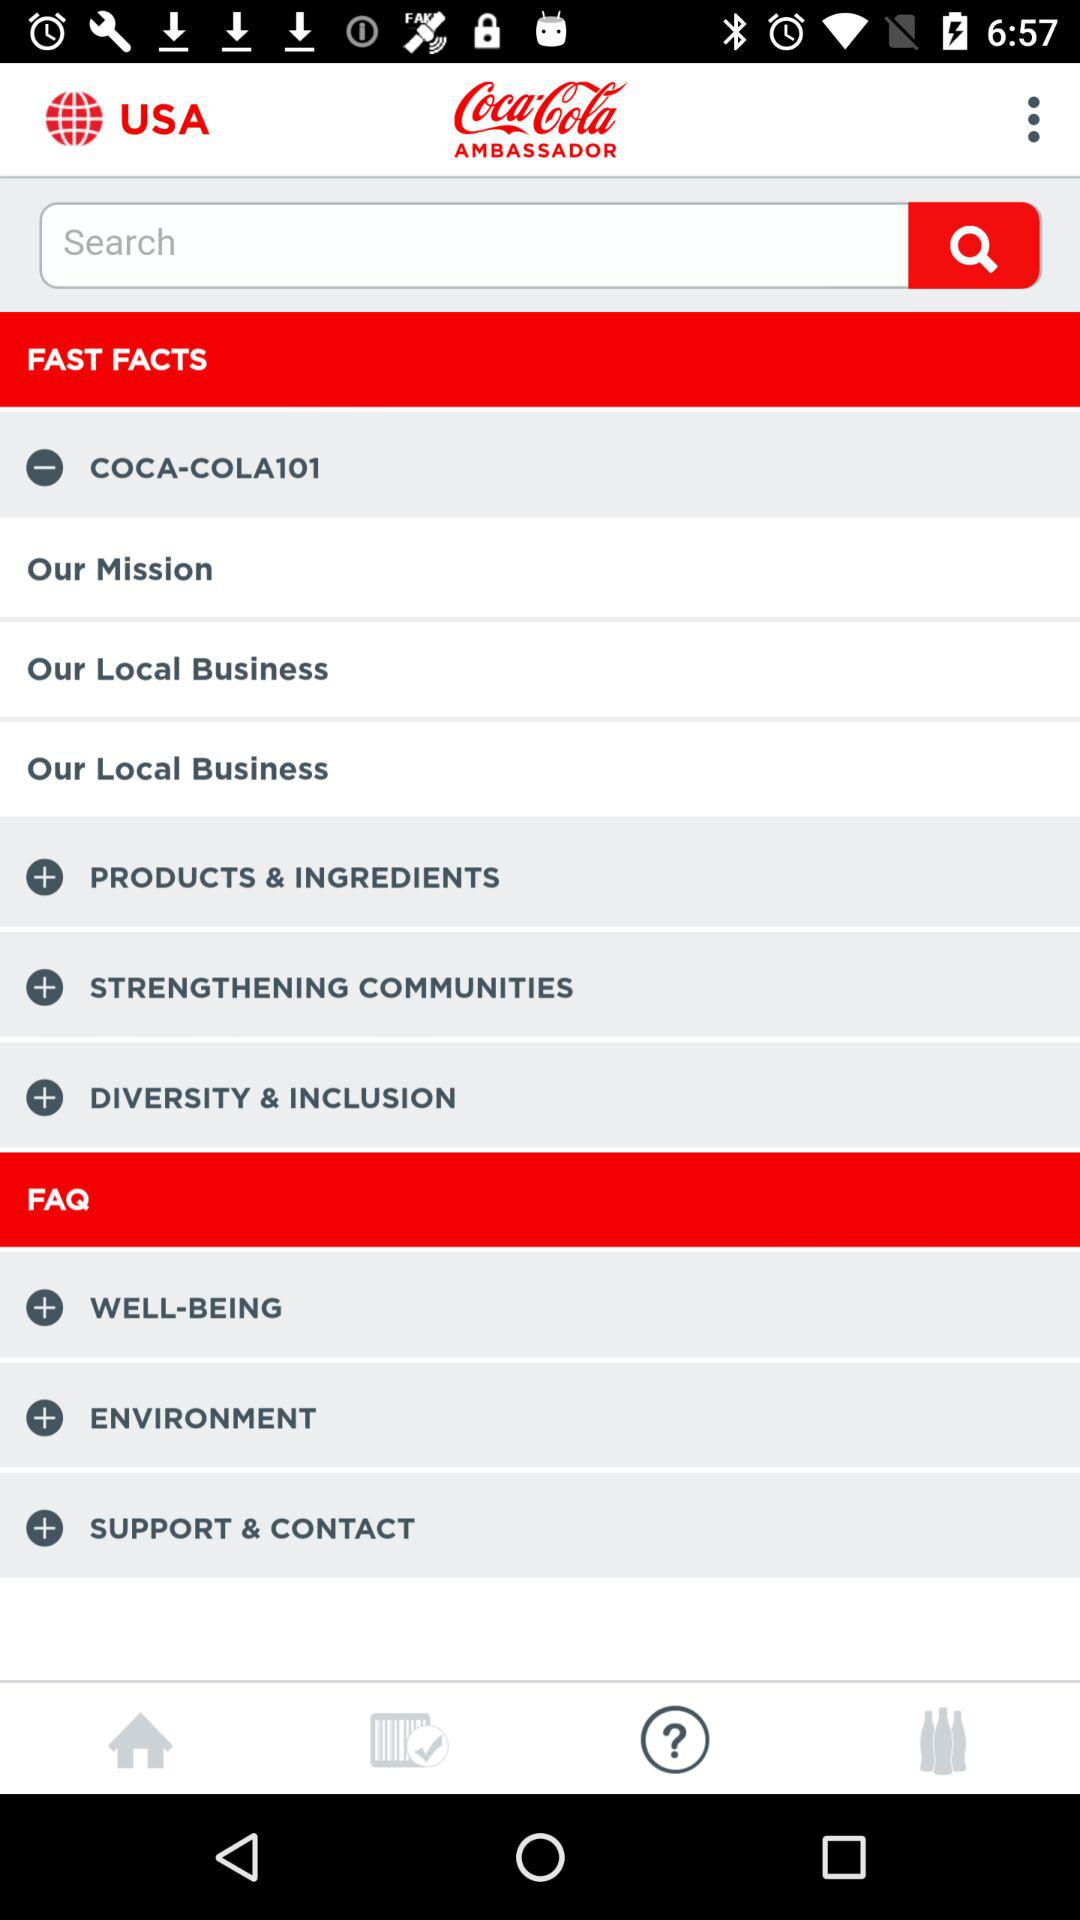What are the selected tabs? The selected tabs are "FAST FACTS" and "FAQ". 